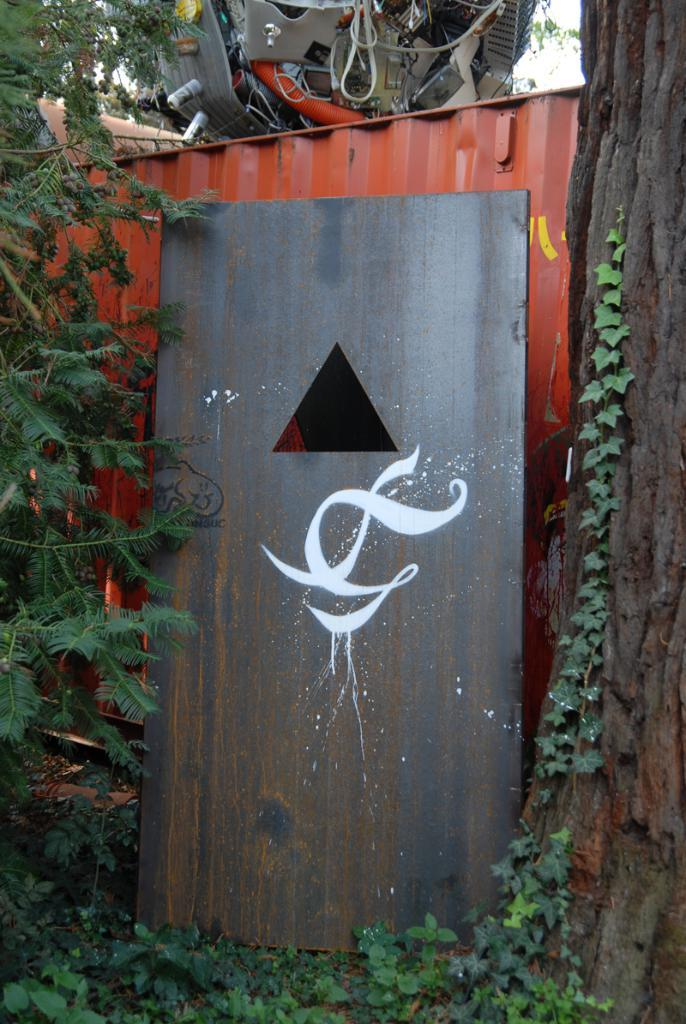What is depicted on the board in the image? There is a painting on a board in the image. What can be seen in the distance in the image? There are trees in the background of the image. What object is present with the painting on the board? There is a metal box in the image. What is the purpose of the engine on the metal box? The engine on the metal box suggests that it might be a generator or some other type of machinery. What type of magic is being performed on the trees in the image? There is no magic being performed in the image; it is a painting on a board with trees in the background. 